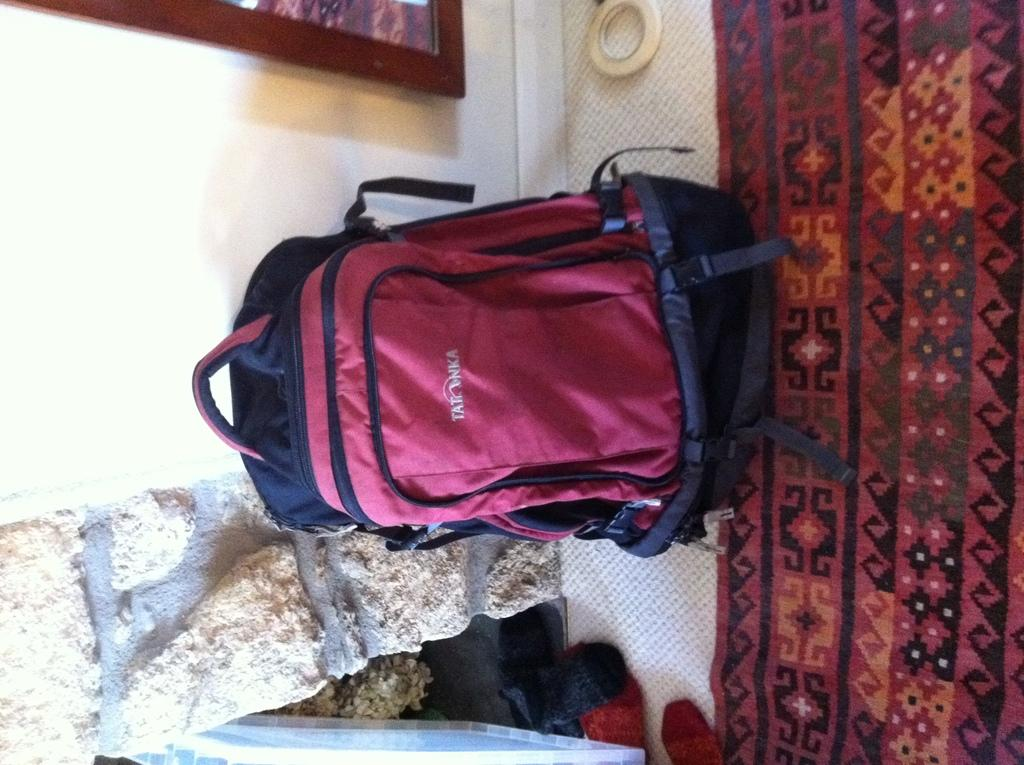What object is placed on the bed in the image? There is a bag on the bed. What can be seen in the background of the image? There is a photo frame and a brick wall in the background. What type of instrument is being played in the image? There is no instrument present in the image. How many bells can be seen hanging from the brick wall in the image? There are no bells visible in the image; only a brick wall and a photo frame are present in the background. 